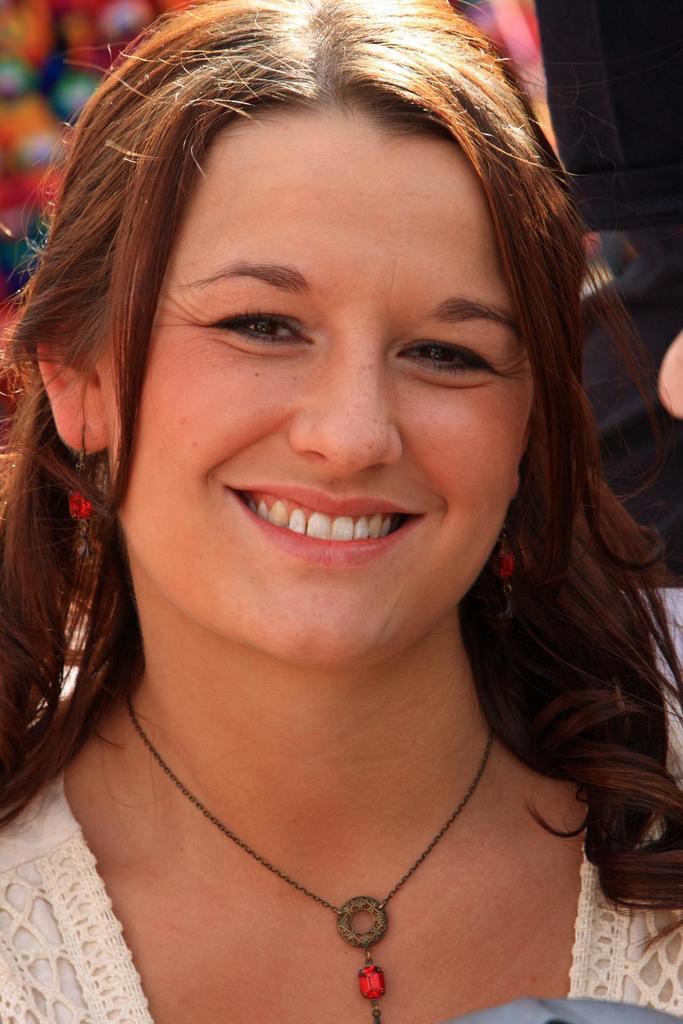How would you summarize this image in a sentence or two? This image is taken outdoors. In this image there is a woman with a smiling face. In the background there are two people. 